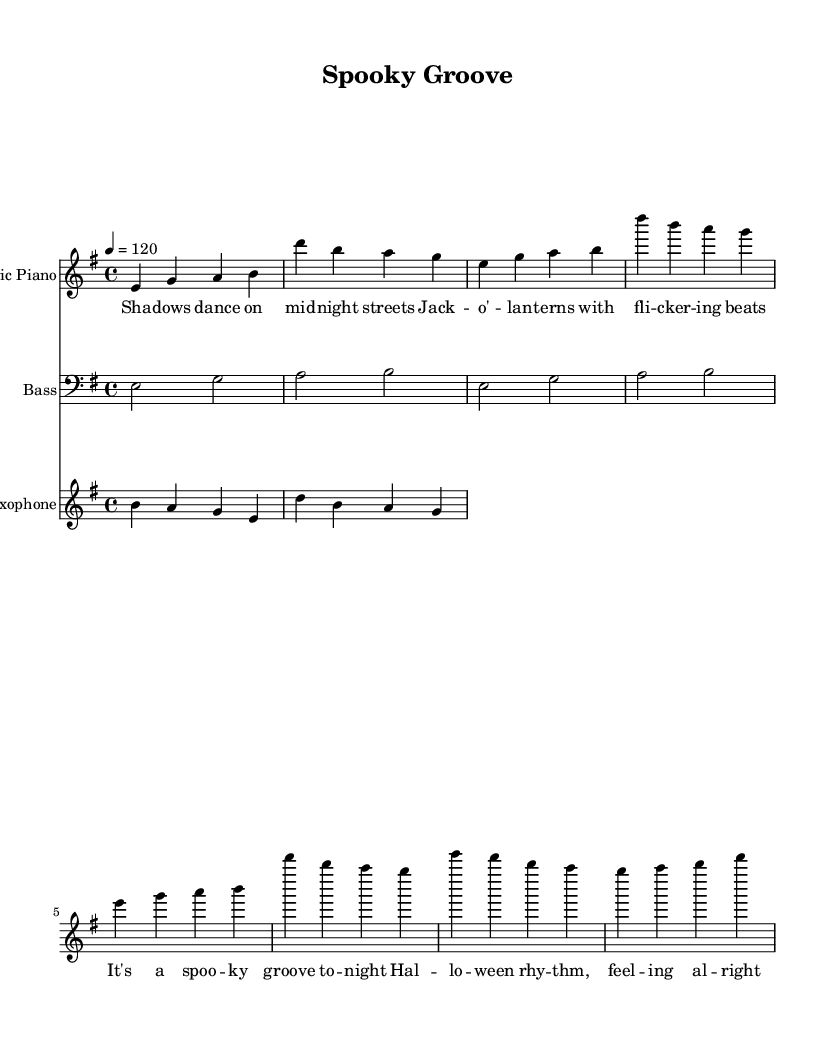What is the key signature of this music? The key signature is E minor, which is indicated by one sharp (F#) on the sheet music.
Answer: E minor What is the time signature of this piece? The time signature shown on the sheet music is 4/4, indicating that there are four quarter-note beats in each measure.
Answer: 4/4 What is the tempo marking for this music? The tempo marking is indicated as 120 beats per minute, which tells the performer to play at this speed.
Answer: 120 How many measures does the electric piano part have? By counting the measures in the electric piano staff, there are 8 measures in total.
Answer: 8 What is the rhythmic feel of this music piece? The rhythm reflects a groovy feel typical in Rhythm and Blues, with syncopation and a functional beat designed for dancing.
Answer: Funky groove Which instruments are featured in this piece? The instruments featured in this music piece are electric piano, bass, and saxophone, as shown in the respective staffs.
Answer: Electric piano, Bass, Saxophone What type of musical form is typical in Rhythm and Blues as seen in this composition? The form often includes verses and a repeating chorus. This piece follows a structured but free-flowing arrangement typical in Rhythm and Blues.
Answer: Verse-Chorus structure 